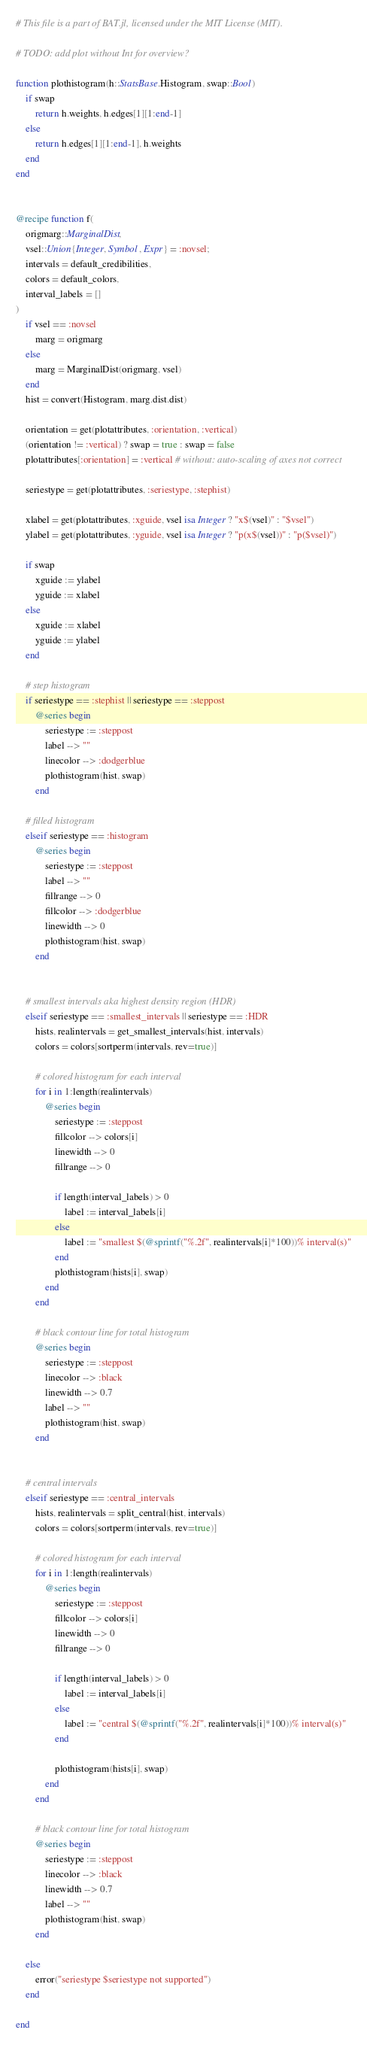Convert code to text. <code><loc_0><loc_0><loc_500><loc_500><_Julia_># This file is a part of BAT.jl, licensed under the MIT License (MIT).

# TODO: add plot without Int for overview?

function plothistogram(h::StatsBase.Histogram, swap::Bool)
    if swap
        return h.weights, h.edges[1][1:end-1]
    else
        return h.edges[1][1:end-1], h.weights
    end
end


@recipe function f(
    origmarg::MarginalDist,
    vsel::Union{Integer, Symbol, Expr} = :novsel;
    intervals = default_credibilities,
    colors = default_colors,
    interval_labels = []
)   
    if vsel == :novsel
        marg = origmarg
    else 
        marg = MarginalDist(origmarg, vsel)
    end
    hist = convert(Histogram, marg.dist.dist)

    orientation = get(plotattributes, :orientation, :vertical)
    (orientation != :vertical) ? swap = true : swap = false
    plotattributes[:orientation] = :vertical # without: auto-scaling of axes not correct

    seriestype = get(plotattributes, :seriestype, :stephist)

    xlabel = get(plotattributes, :xguide, vsel isa Integer ? "x$(vsel)" : "$vsel")
    ylabel = get(plotattributes, :yguide, vsel isa Integer ? "p(x$(vsel))" : "p($vsel)")

    if swap
        xguide := ylabel
        yguide := xlabel
    else
        xguide := xlabel
        yguide := ylabel
    end

    # step histogram
    if seriestype == :stephist || seriestype == :steppost
        @series begin
            seriestype := :steppost
            label --> ""
            linecolor --> :dodgerblue
            plothistogram(hist, swap)
        end

    # filled histogram
    elseif seriestype == :histogram
        @series begin
            seriestype := :steppost
            label --> ""
            fillrange --> 0
            fillcolor --> :dodgerblue
            linewidth --> 0
            plothistogram(hist, swap)
        end


    # smallest intervals aka highest density region (HDR)
    elseif seriestype == :smallest_intervals || seriestype == :HDR
        hists, realintervals = get_smallest_intervals(hist, intervals)
        colors = colors[sortperm(intervals, rev=true)]

        # colored histogram for each interval
        for i in 1:length(realintervals)
            @series begin
                seriestype := :steppost
                fillcolor --> colors[i]
                linewidth --> 0
                fillrange --> 0

                if length(interval_labels) > 0
                    label := interval_labels[i]
                else
                    label := "smallest $(@sprintf("%.2f", realintervals[i]*100))% interval(s)"
                end
                plothistogram(hists[i], swap)
            end
        end

        # black contour line for total histogram
        @series begin
            seriestype := :steppost
            linecolor --> :black
            linewidth --> 0.7
            label --> ""
            plothistogram(hist, swap)
        end


    # central intervals
    elseif seriestype == :central_intervals
        hists, realintervals = split_central(hist, intervals)
        colors = colors[sortperm(intervals, rev=true)]

        # colored histogram for each interval
        for i in 1:length(realintervals)
            @series begin
                seriestype := :steppost
                fillcolor --> colors[i]
                linewidth --> 0
                fillrange --> 0

                if length(interval_labels) > 0
                    label := interval_labels[i]
                else
                    label := "central $(@sprintf("%.2f", realintervals[i]*100))% interval(s)"
                end

                plothistogram(hists[i], swap)
            end
        end

        # black contour line for total histogram
        @series begin
            seriestype := :steppost
            linecolor --> :black
            linewidth --> 0.7
            label --> ""
            plothistogram(hist, swap)
        end

    else
        error("seriestype $seriestype not supported")
    end

end
</code> 